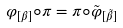<formula> <loc_0><loc_0><loc_500><loc_500>\varphi _ { [ \beta ] } \circ \pi = \pi \circ \tilde { \varphi } _ { [ \tilde { \beta } ] }</formula> 